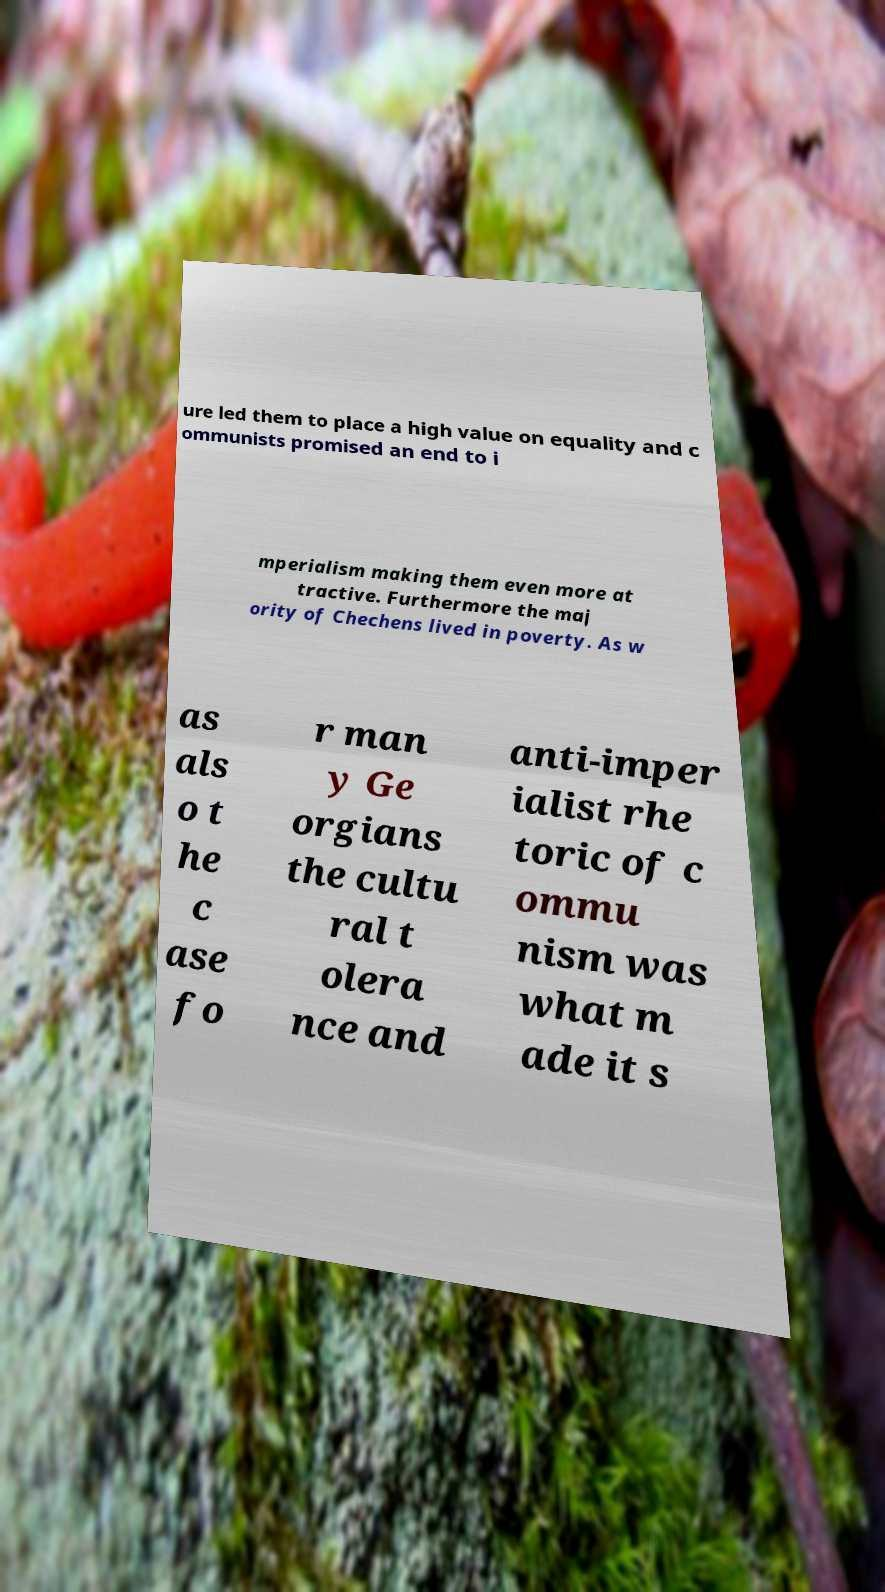Please read and relay the text visible in this image. What does it say? ure led them to place a high value on equality and c ommunists promised an end to i mperialism making them even more at tractive. Furthermore the maj ority of Chechens lived in poverty. As w as als o t he c ase fo r man y Ge orgians the cultu ral t olera nce and anti-imper ialist rhe toric of c ommu nism was what m ade it s 